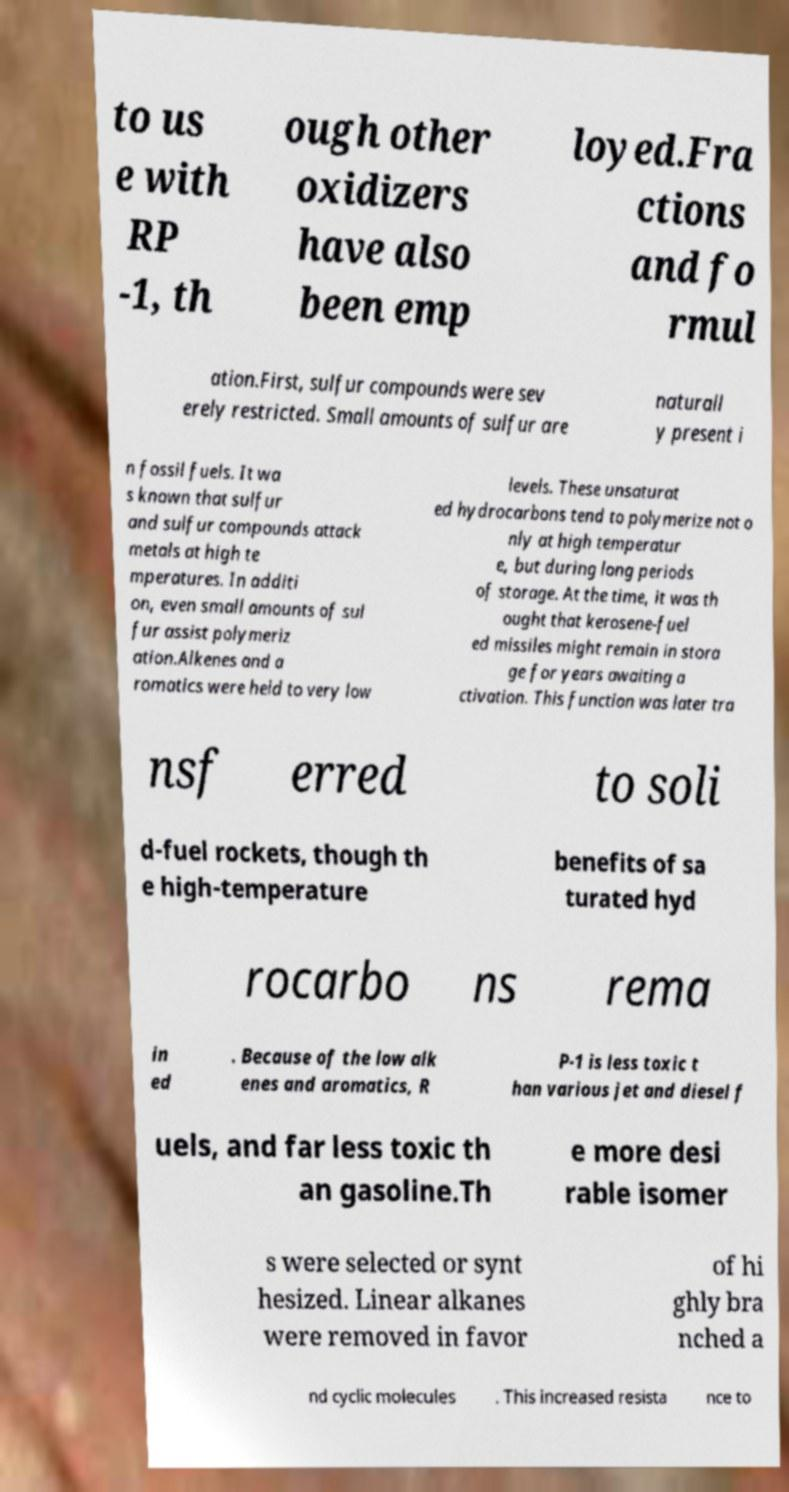There's text embedded in this image that I need extracted. Can you transcribe it verbatim? to us e with RP -1, th ough other oxidizers have also been emp loyed.Fra ctions and fo rmul ation.First, sulfur compounds were sev erely restricted. Small amounts of sulfur are naturall y present i n fossil fuels. It wa s known that sulfur and sulfur compounds attack metals at high te mperatures. In additi on, even small amounts of sul fur assist polymeriz ation.Alkenes and a romatics were held to very low levels. These unsaturat ed hydrocarbons tend to polymerize not o nly at high temperatur e, but during long periods of storage. At the time, it was th ought that kerosene-fuel ed missiles might remain in stora ge for years awaiting a ctivation. This function was later tra nsf erred to soli d-fuel rockets, though th e high-temperature benefits of sa turated hyd rocarbo ns rema in ed . Because of the low alk enes and aromatics, R P-1 is less toxic t han various jet and diesel f uels, and far less toxic th an gasoline.Th e more desi rable isomer s were selected or synt hesized. Linear alkanes were removed in favor of hi ghly bra nched a nd cyclic molecules . This increased resista nce to 